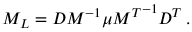Convert formula to latex. <formula><loc_0><loc_0><loc_500><loc_500>M _ { L } = D M ^ { - 1 } \mu { M ^ { T } } ^ { - 1 } D ^ { T } \, .</formula> 